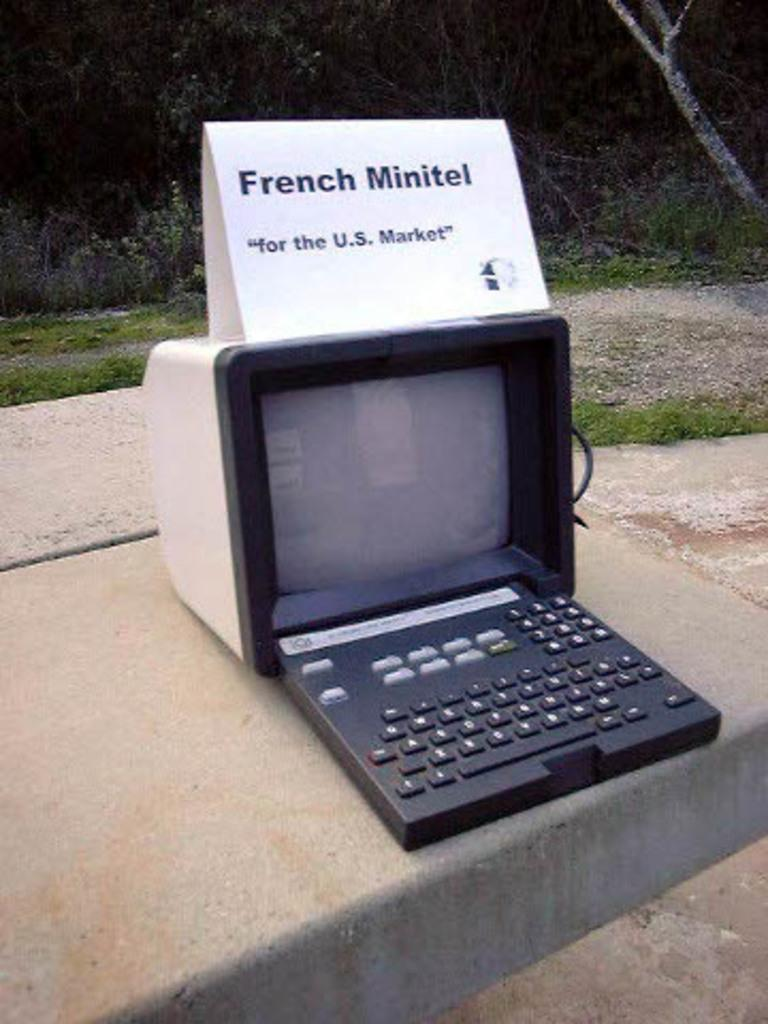<image>
Render a clear and concise summary of the photo. A large screen with a keyboard below it has a sign on it that has the words French Minitel. 